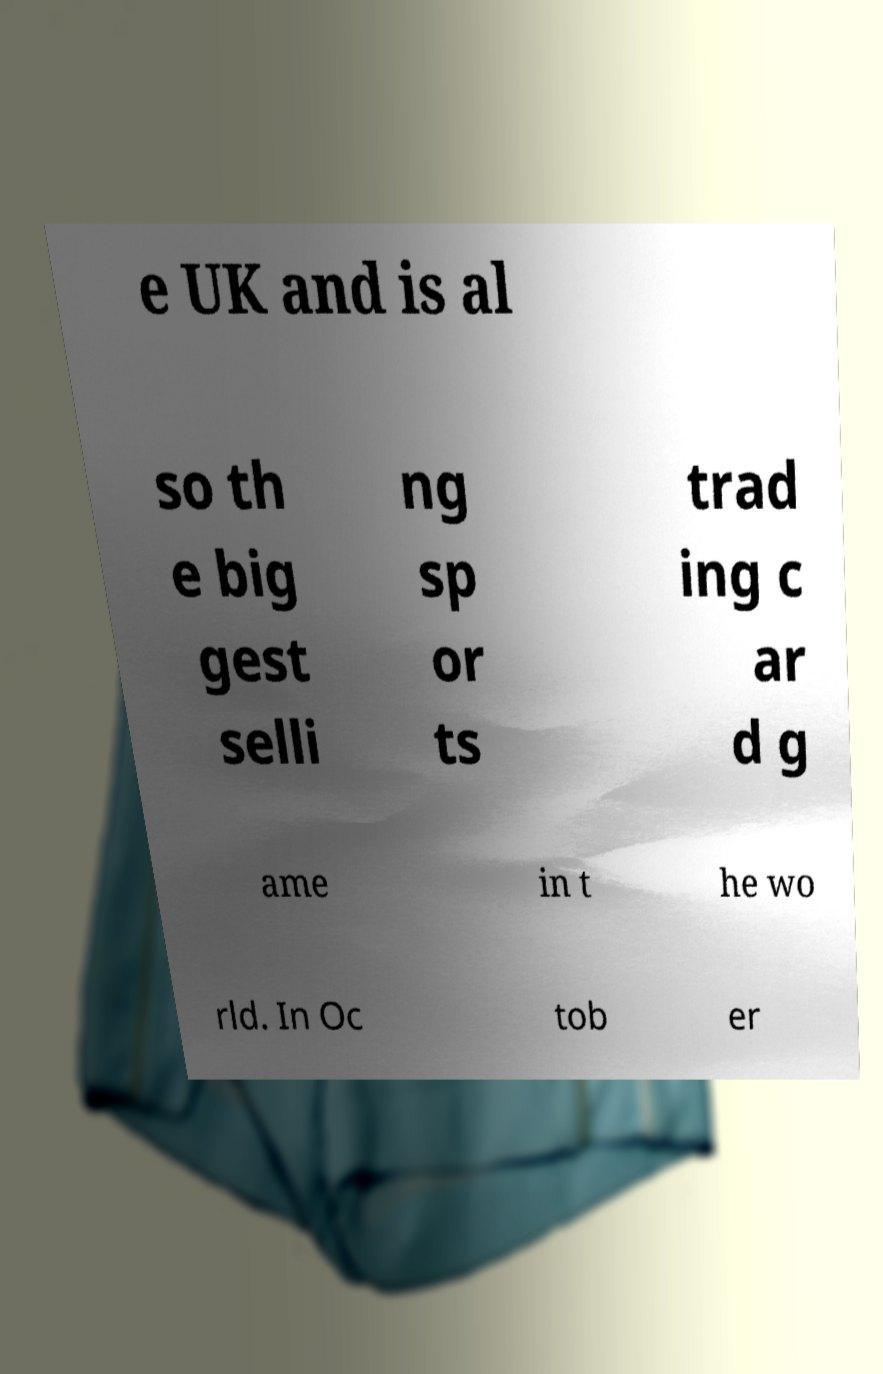Could you assist in decoding the text presented in this image and type it out clearly? e UK and is al so th e big gest selli ng sp or ts trad ing c ar d g ame in t he wo rld. In Oc tob er 